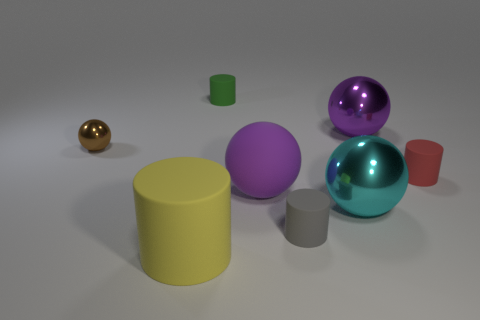If these objects were part of a game, what could be their potential use? If these objects were in a game, they could serve various purposes such as collectibles, puzzle elements where each shape fits a specific location, or even as part of a material identification challenge. 